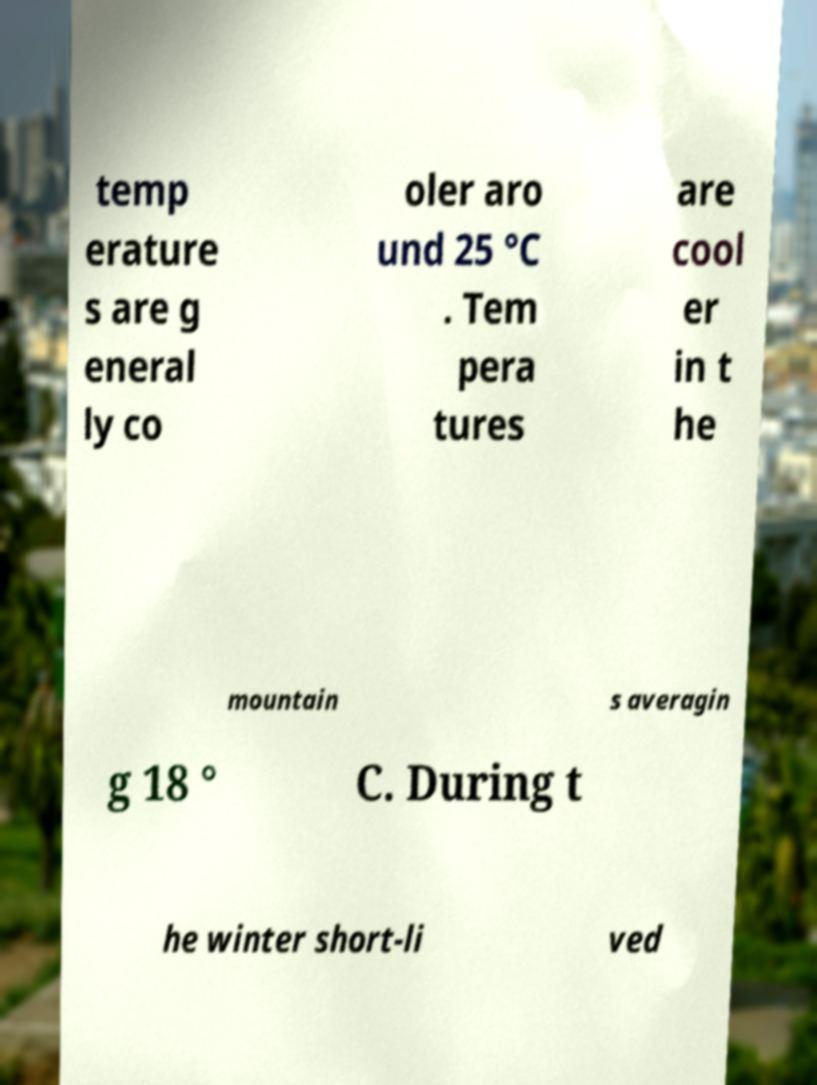Could you extract and type out the text from this image? temp erature s are g eneral ly co oler aro und 25 °C . Tem pera tures are cool er in t he mountain s averagin g 18 ° C. During t he winter short-li ved 